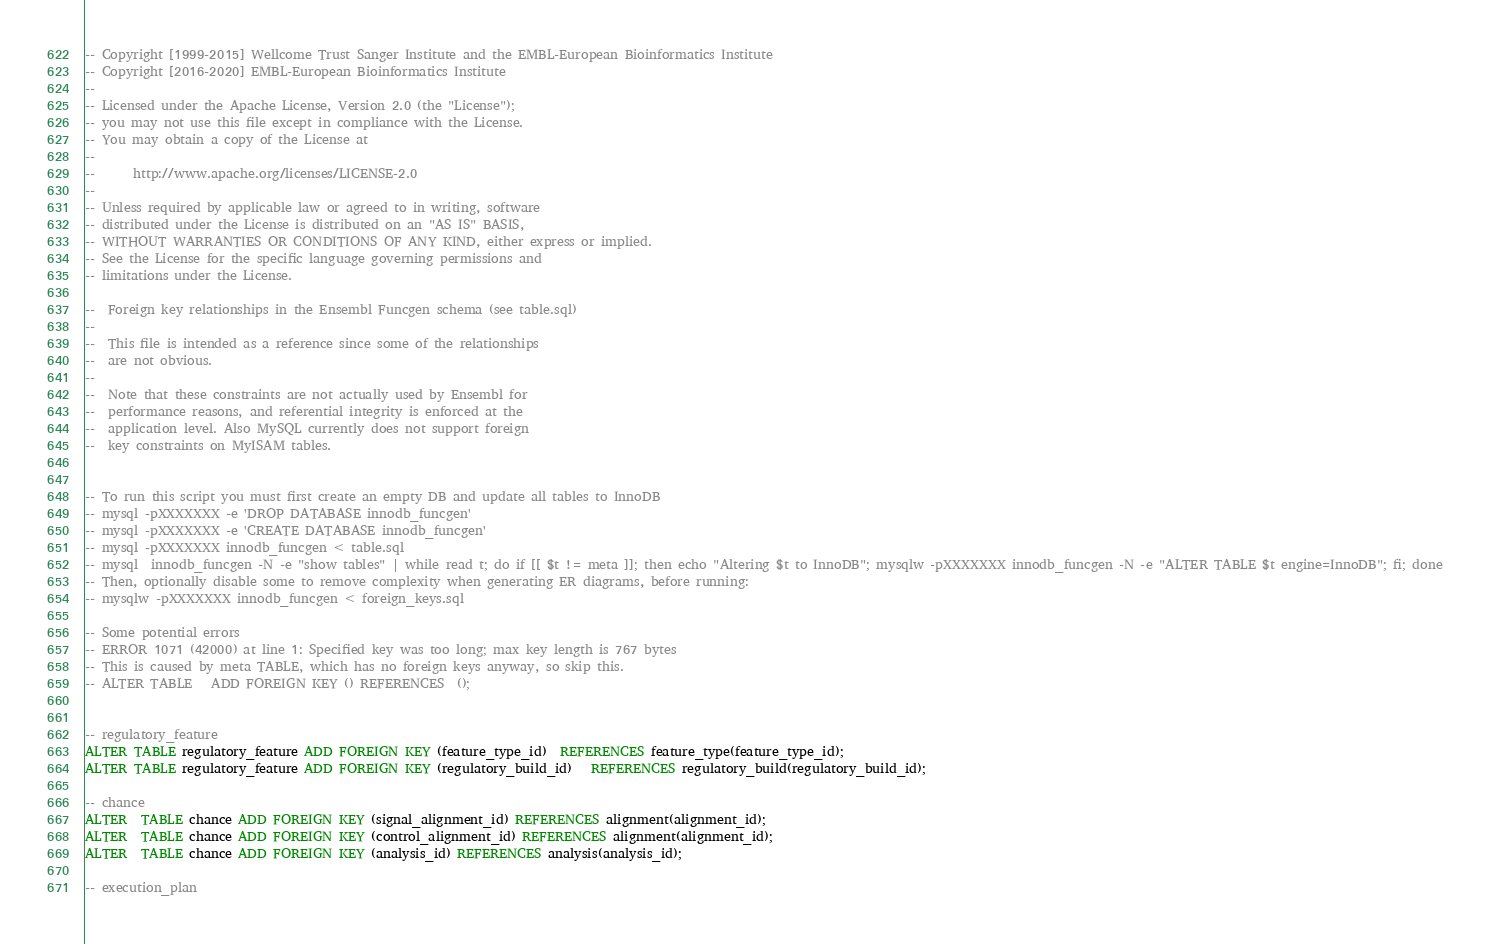<code> <loc_0><loc_0><loc_500><loc_500><_SQL_>-- Copyright [1999-2015] Wellcome Trust Sanger Institute and the EMBL-European Bioinformatics Institute
-- Copyright [2016-2020] EMBL-European Bioinformatics Institute
--
-- Licensed under the Apache License, Version 2.0 (the "License");
-- you may not use this file except in compliance with the License.
-- You may obtain a copy of the License at
--
--      http://www.apache.org/licenses/LICENSE-2.0
--
-- Unless required by applicable law or agreed to in writing, software
-- distributed under the License is distributed on an "AS IS" BASIS,
-- WITHOUT WARRANTIES OR CONDITIONS OF ANY KIND, either express or implied.
-- See the License for the specific language governing permissions and
-- limitations under the License.

--  Foreign key relationships in the Ensembl Funcgen schema (see table.sql)
--
--  This file is intended as a reference since some of the relationships
--  are not obvious.
--
--  Note that these constraints are not actually used by Ensembl for
--  performance reasons, and referential integrity is enforced at the
--  application level. Also MySQL currently does not support foreign
--  key constraints on MyISAM tables.


-- To run this script you must first create an empty DB and update all tables to InnoDB
-- mysql -pXXXXXXX -e 'DROP DATABASE innodb_funcgen'
-- mysql -pXXXXXXX -e 'CREATE DATABASE innodb_funcgen'
-- mysql -pXXXXXXX innodb_funcgen < table.sql
-- mysql  innodb_funcgen -N -e "show tables" | while read t; do if [[ $t != meta ]]; then echo "Altering $t to InnoDB"; mysqlw -pXXXXXXX innodb_funcgen -N -e "ALTER TABLE $t engine=InnoDB"; fi; done
-- Then, optionally disable some to remove complexity when generating ER diagrams, before running:
-- mysqlw -pXXXXXXX innodb_funcgen < foreign_keys.sql

-- Some potential errors
-- ERROR 1071 (42000) at line 1: Specified key was too long; max key length is 767 bytes
-- This is caused by meta TABLE, which has no foreign keys anyway, so skip this.
-- ALTER TABLE   ADD FOREIGN KEY () REFERENCES  ();


-- regulatory_feature
ALTER TABLE regulatory_feature ADD FOREIGN KEY (feature_type_id)  REFERENCES feature_type(feature_type_id);
ALTER TABLE regulatory_feature ADD FOREIGN KEY (regulatory_build_id)   REFERENCES regulatory_build(regulatory_build_id);

-- chance
ALTER  TABLE chance ADD FOREIGN KEY (signal_alignment_id) REFERENCES alignment(alignment_id);
ALTER  TABLE chance ADD FOREIGN KEY (control_alignment_id) REFERENCES alignment(alignment_id);
ALTER  TABLE chance ADD FOREIGN KEY (analysis_id) REFERENCES analysis(analysis_id);

-- execution_plan</code> 